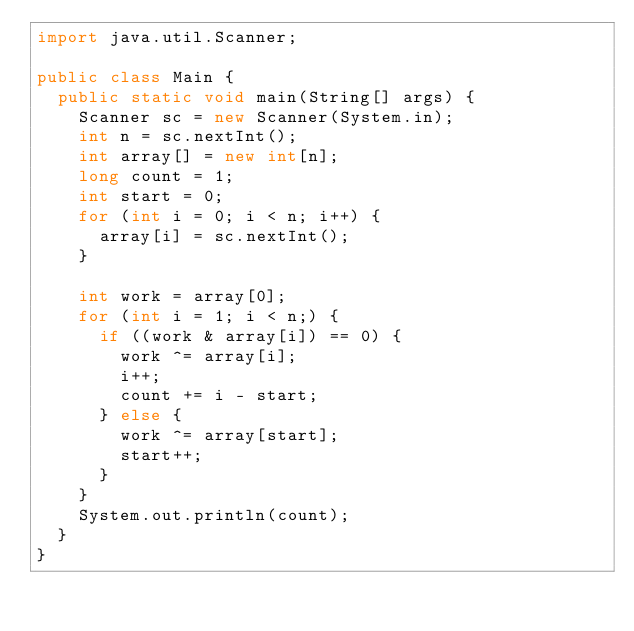Convert code to text. <code><loc_0><loc_0><loc_500><loc_500><_Java_>import java.util.Scanner;
 
public class Main {
  public static void main(String[] args) {
    Scanner sc = new Scanner(System.in);
    int n = sc.nextInt();
    int array[] = new int[n];
    long count = 1;
    int start = 0;
    for (int i = 0; i < n; i++) {
      array[i] = sc.nextInt();
    }
    
    int work = array[0];
    for (int i = 1; i < n;) {
      if ((work & array[i]) == 0) {
        work ^= array[i];
        i++;
        count += i - start;
      } else {
        work ^= array[start];
        start++;
      }
    }
    System.out.println(count);
  }
}</code> 